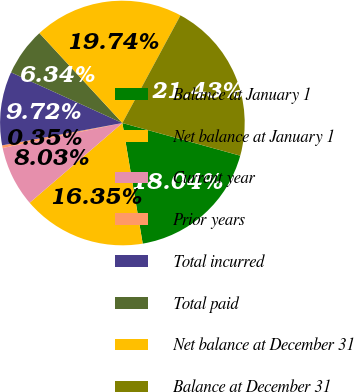Convert chart. <chart><loc_0><loc_0><loc_500><loc_500><pie_chart><fcel>Balance at January 1<fcel>Net balance at January 1<fcel>Current year<fcel>Prior years<fcel>Total incurred<fcel>Total paid<fcel>Net balance at December 31<fcel>Balance at December 31<nl><fcel>18.04%<fcel>16.35%<fcel>8.03%<fcel>0.35%<fcel>9.72%<fcel>6.34%<fcel>19.74%<fcel>21.43%<nl></chart> 